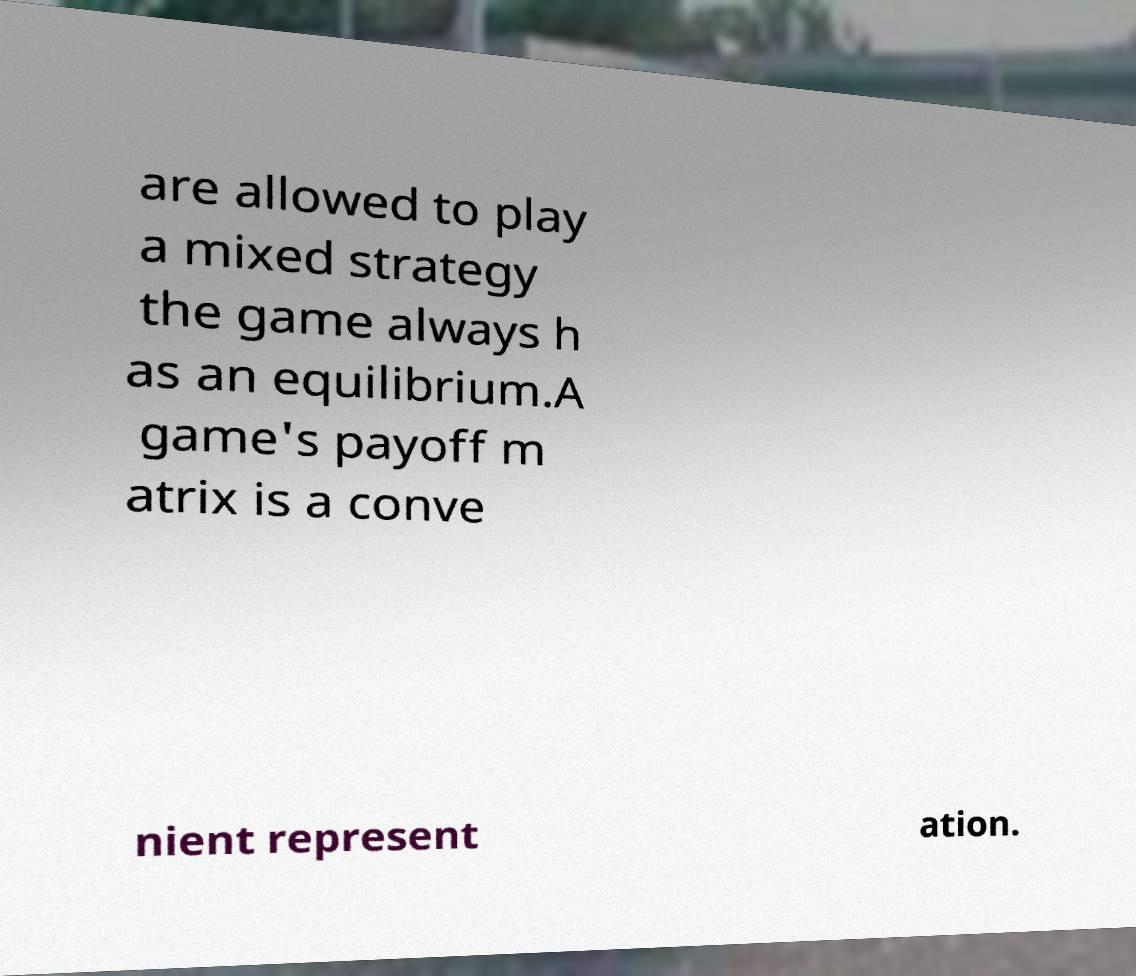Please identify and transcribe the text found in this image. are allowed to play a mixed strategy the game always h as an equilibrium.A game's payoff m atrix is a conve nient represent ation. 